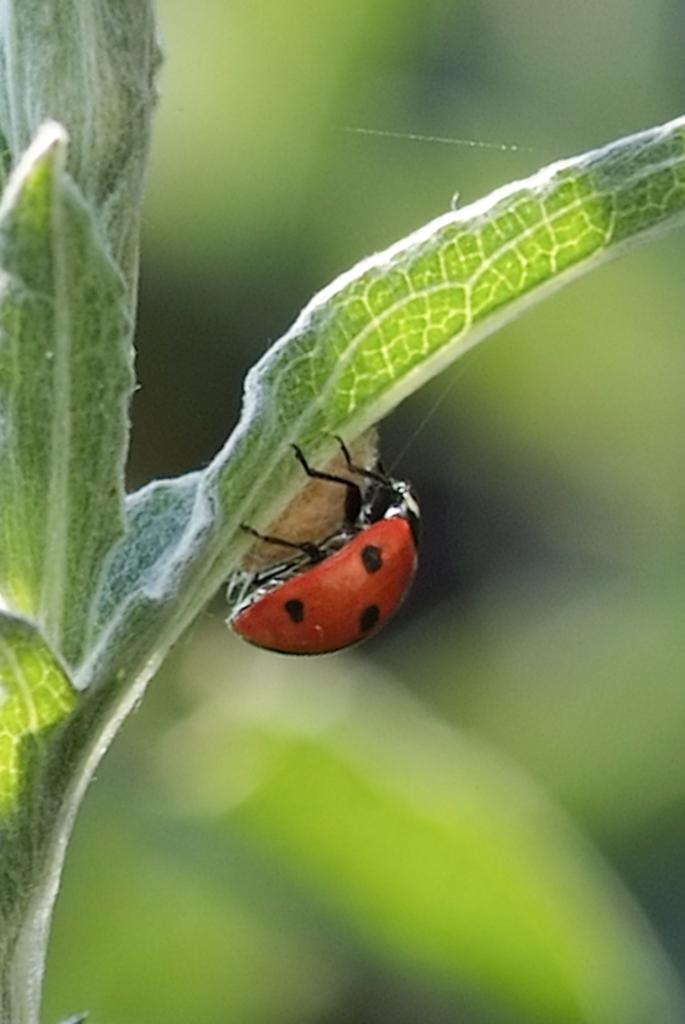What color are the leaves in the image? The leaves in the image are green. What is present on the leaves? There is a bug on the leaves. Can you describe the background of the image? The background of the image is blurry. How does the queen use the key to unlock the door in the image? There is no queen or door present in the image; it features green leaves with a bug on them and a blurry background. 